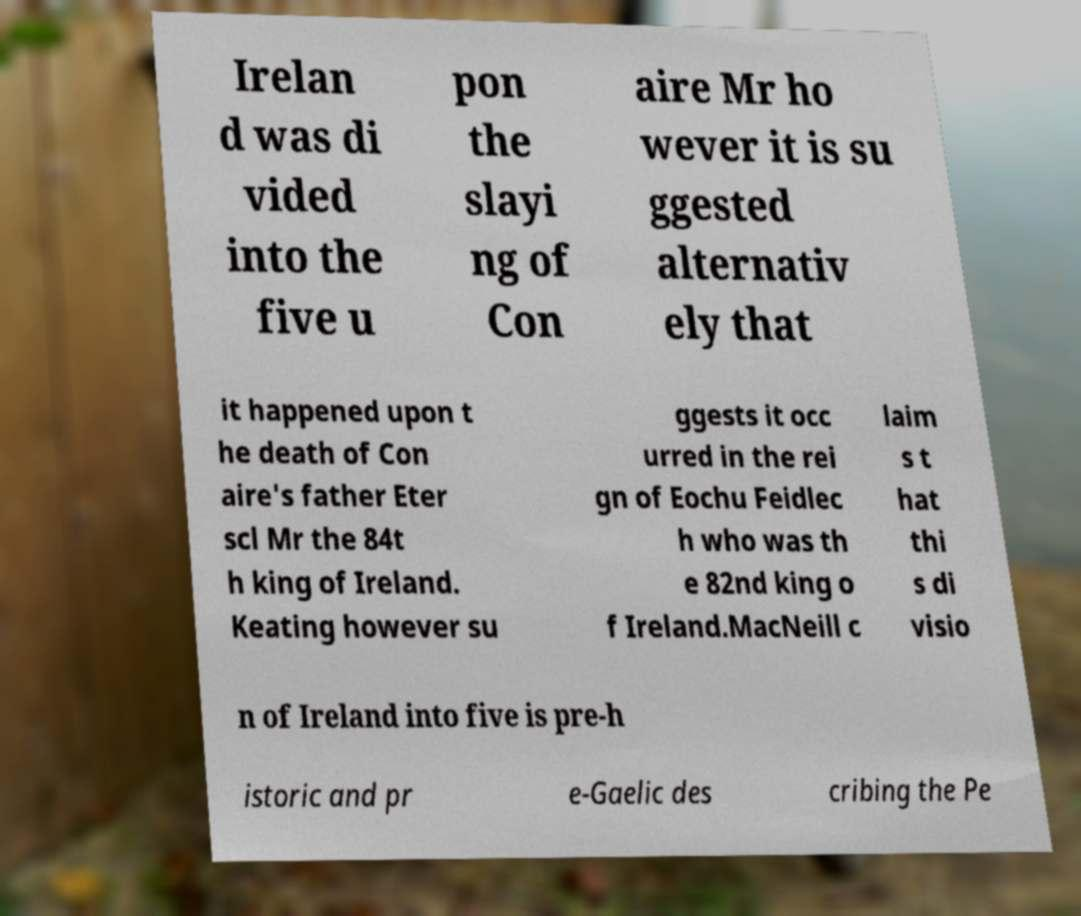Could you extract and type out the text from this image? Irelan d was di vided into the five u pon the slayi ng of Con aire Mr ho wever it is su ggested alternativ ely that it happened upon t he death of Con aire's father Eter scl Mr the 84t h king of Ireland. Keating however su ggests it occ urred in the rei gn of Eochu Feidlec h who was th e 82nd king o f Ireland.MacNeill c laim s t hat thi s di visio n of Ireland into five is pre-h istoric and pr e-Gaelic des cribing the Pe 